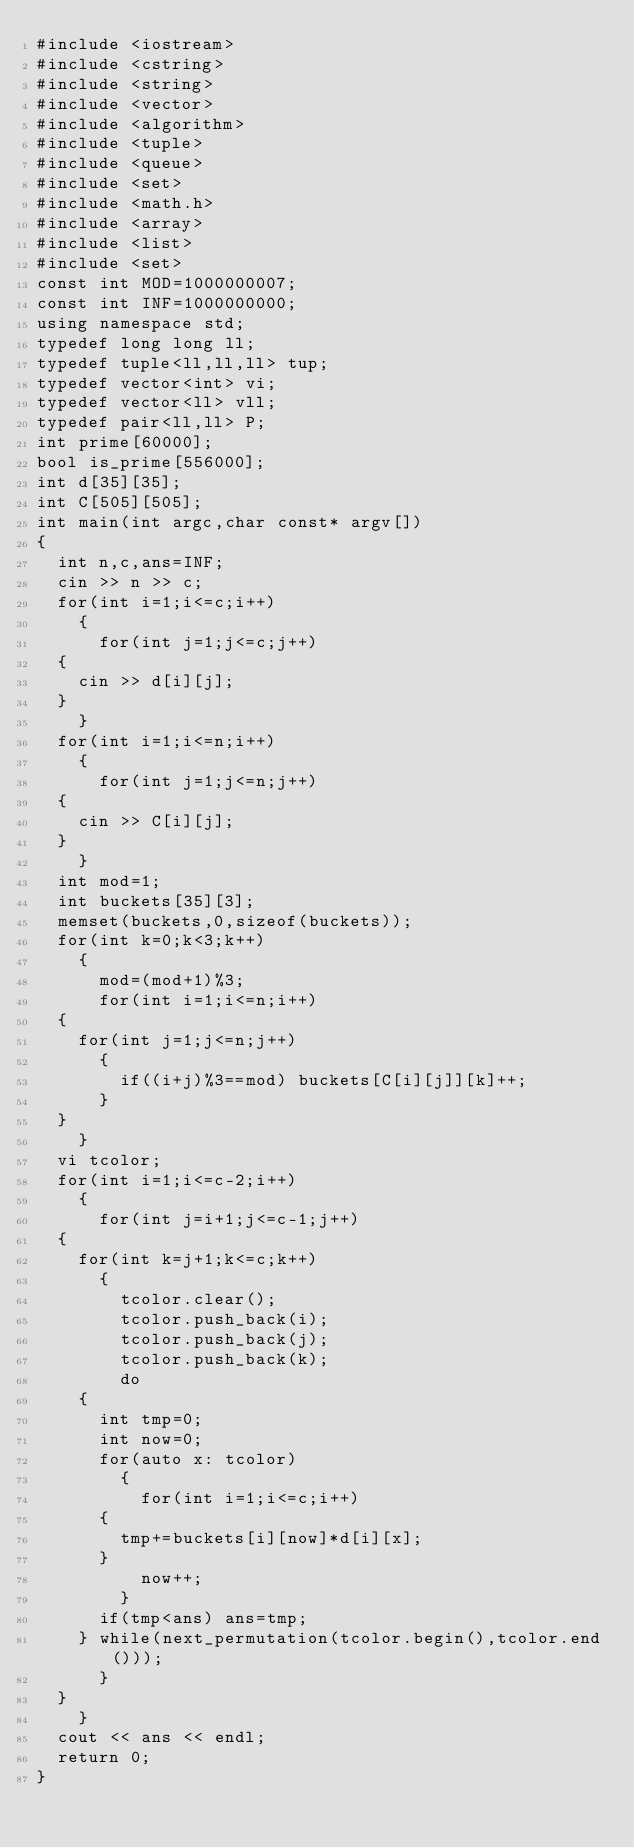Convert code to text. <code><loc_0><loc_0><loc_500><loc_500><_C++_>#include <iostream>
#include <cstring>
#include <string>
#include <vector>
#include <algorithm>
#include <tuple>
#include <queue>
#include <set>
#include <math.h>
#include <array>
#include <list>
#include <set>
const int MOD=1000000007;
const int INF=1000000000;
using namespace std;
typedef long long ll;
typedef tuple<ll,ll,ll> tup;
typedef vector<int> vi;
typedef vector<ll> vll;
typedef pair<ll,ll> P;
int prime[60000];
bool is_prime[556000];
int d[35][35];
int C[505][505];
int main(int argc,char const* argv[])
{
  int n,c,ans=INF;
  cin >> n >> c;
  for(int i=1;i<=c;i++)
    {
      for(int j=1;j<=c;j++)
	{
	  cin >> d[i][j];
	}
    }
  for(int i=1;i<=n;i++)
    {
      for(int j=1;j<=n;j++)
	{
	  cin >> C[i][j];
	}
    }
  int mod=1;
  int buckets[35][3];
  memset(buckets,0,sizeof(buckets));
  for(int k=0;k<3;k++)
    {
      mod=(mod+1)%3;
      for(int i=1;i<=n;i++)
	{
	  for(int j=1;j<=n;j++)
	    {
	      if((i+j)%3==mod) buckets[C[i][j]][k]++;
	    }
	}
    }
  vi tcolor;
  for(int i=1;i<=c-2;i++)
    {
      for(int j=i+1;j<=c-1;j++)
	{
	  for(int k=j+1;k<=c;k++)
	    {
	      tcolor.clear();
	      tcolor.push_back(i);
	      tcolor.push_back(j);
	      tcolor.push_back(k);
	      do
		{
		  int tmp=0;
		  int now=0;
		  for(auto x: tcolor) 
		    {
		      for(int i=1;i<=c;i++)
			{
			  tmp+=buckets[i][now]*d[i][x];
			}
		      now++;
		    }
		  if(tmp<ans) ans=tmp;
		} while(next_permutation(tcolor.begin(),tcolor.end()));
	    }
	}
    }
  cout << ans << endl;
  return 0;
}

</code> 